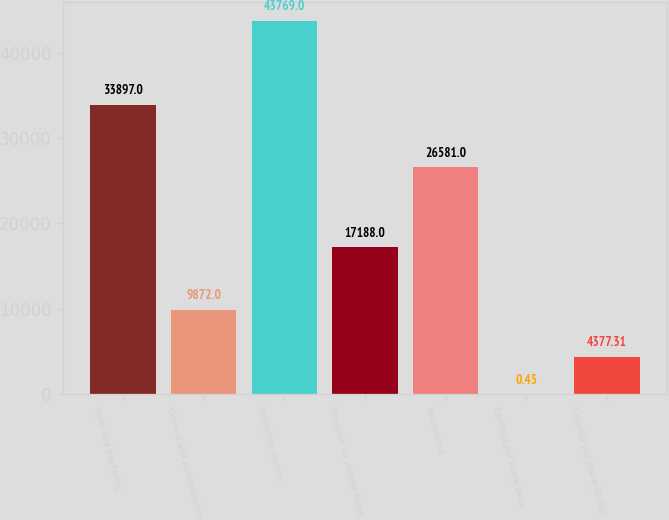Convert chart. <chart><loc_0><loc_0><loc_500><loc_500><bar_chart><fcel>Sales and marketing<fcel>General and administrative<fcel>Operating income<fcel>Provision for income taxes<fcel>Net income<fcel>Earnings per share basic<fcel>Earnings per share diluted<nl><fcel>33897<fcel>9872<fcel>43769<fcel>17188<fcel>26581<fcel>0.45<fcel>4377.31<nl></chart> 